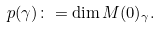<formula> <loc_0><loc_0><loc_500><loc_500>p ( \gamma ) \colon = \dim M ( 0 ) _ { \gamma } .</formula> 